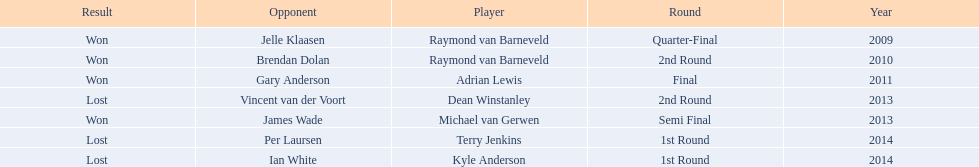What are all the years? 2009, 2010, 2011, 2013, 2013, 2014, 2014. Of these, which ones are 2014? 2014, 2014. Of these dates which one is associated with a player other than kyle anderson? 2014. What is the player name associated with this year? Terry Jenkins. 